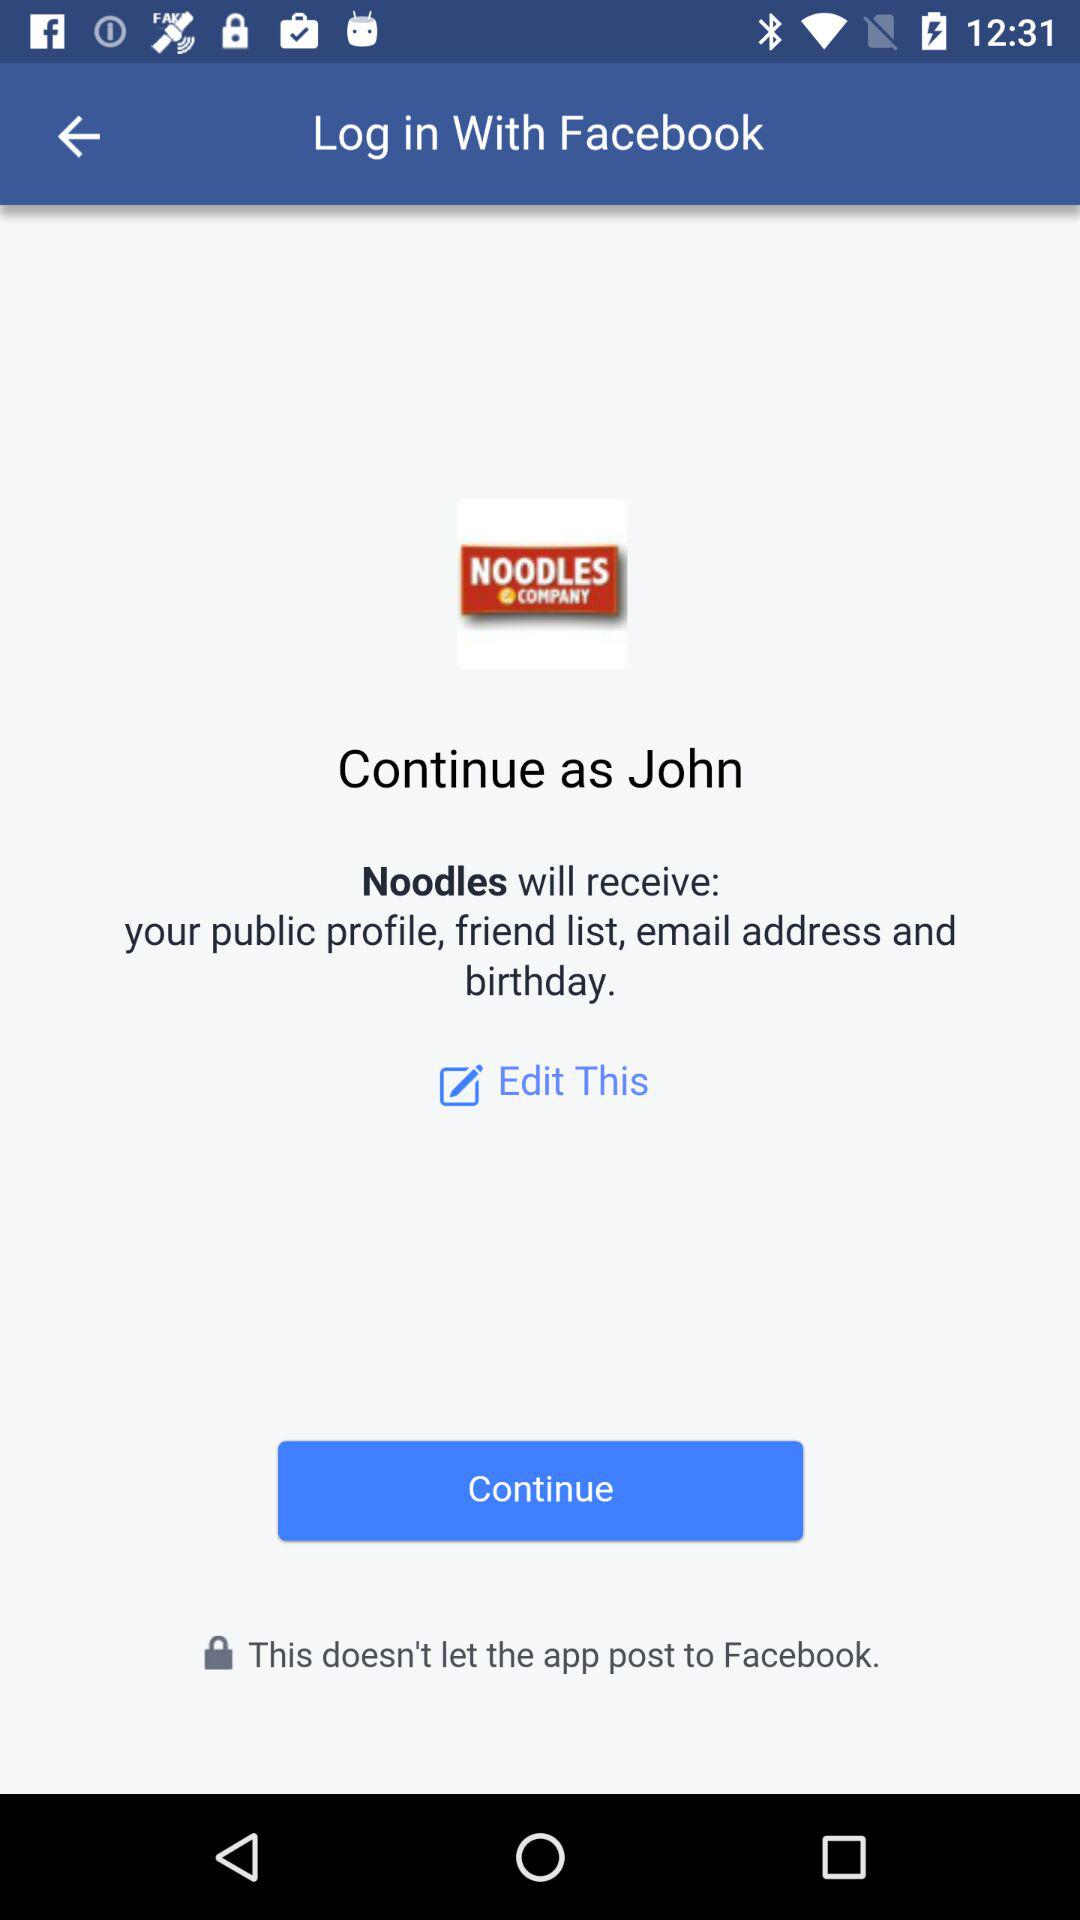What is the user name? The user name is John. 